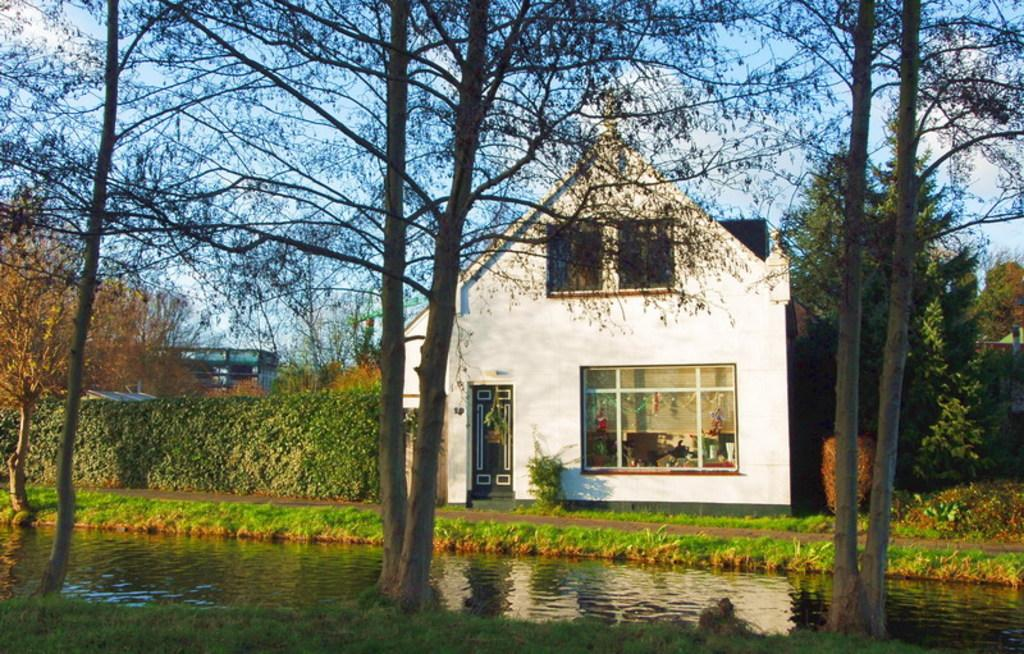What type of natural elements can be seen in the image? There are trees and water visible in the image. What type of structures are present in the image? There is a house and a building in the image. What is visible in the background of the image? The sky is visible in the background of the image. Can you tell me how many friends are flying kites in the image? There are no friends or kites present in the image. What type of committee is meeting in the image? There is no committee meeting in the image; it features trees, water, a house, a building, and the sky. 